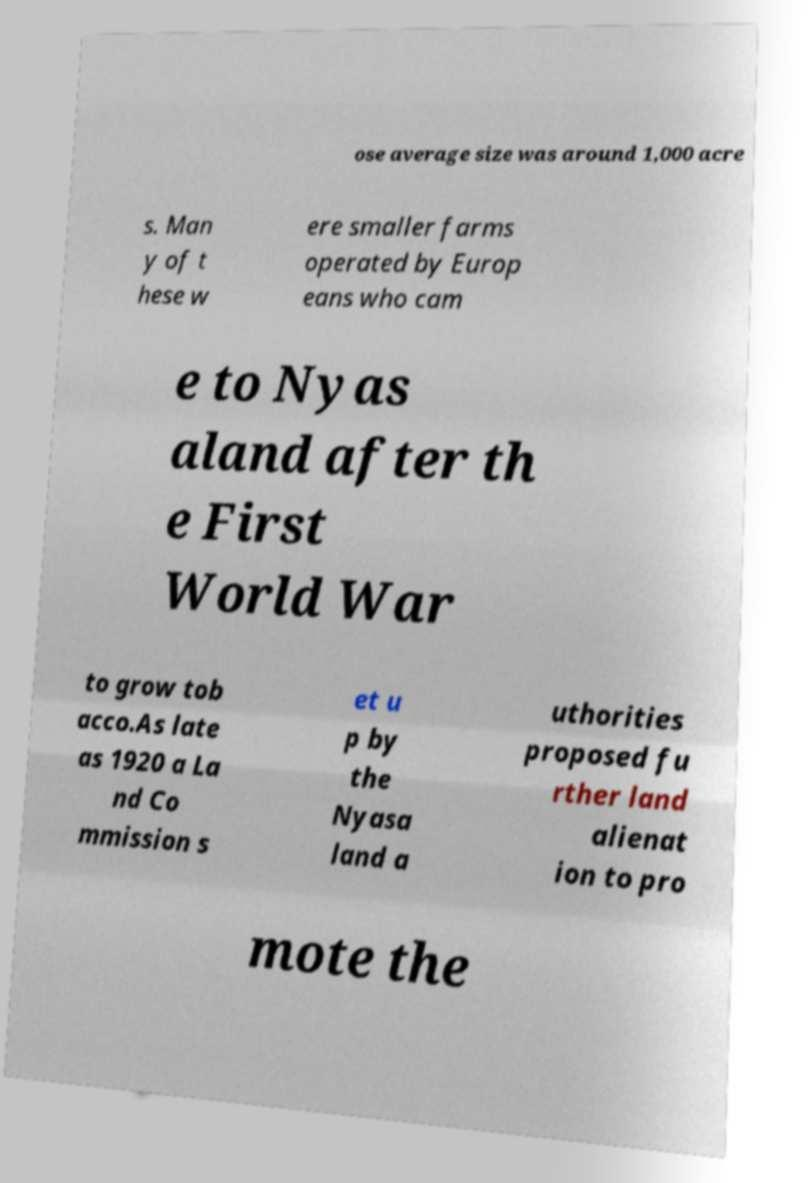There's text embedded in this image that I need extracted. Can you transcribe it verbatim? ose average size was around 1,000 acre s. Man y of t hese w ere smaller farms operated by Europ eans who cam e to Nyas aland after th e First World War to grow tob acco.As late as 1920 a La nd Co mmission s et u p by the Nyasa land a uthorities proposed fu rther land alienat ion to pro mote the 